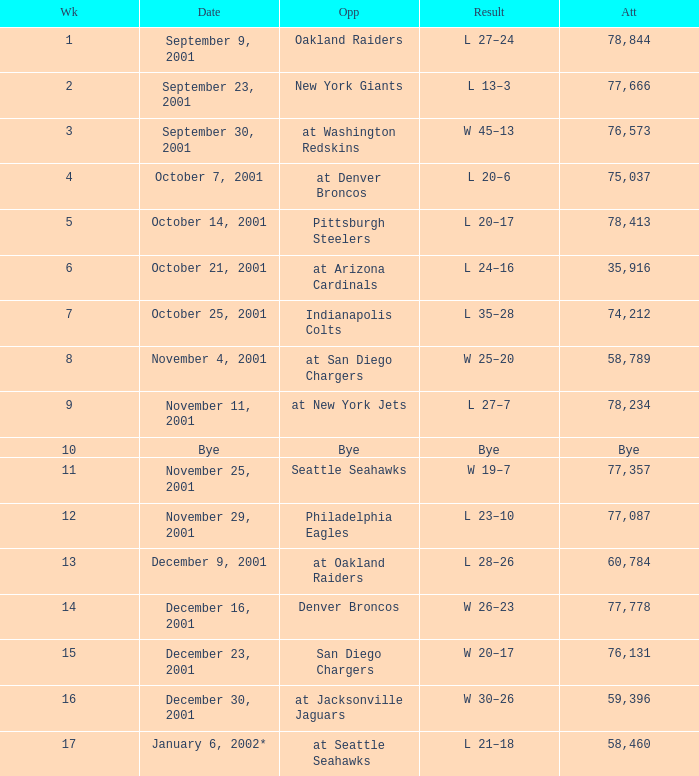How many attended the game on December 16, 2001? 77778.0. 